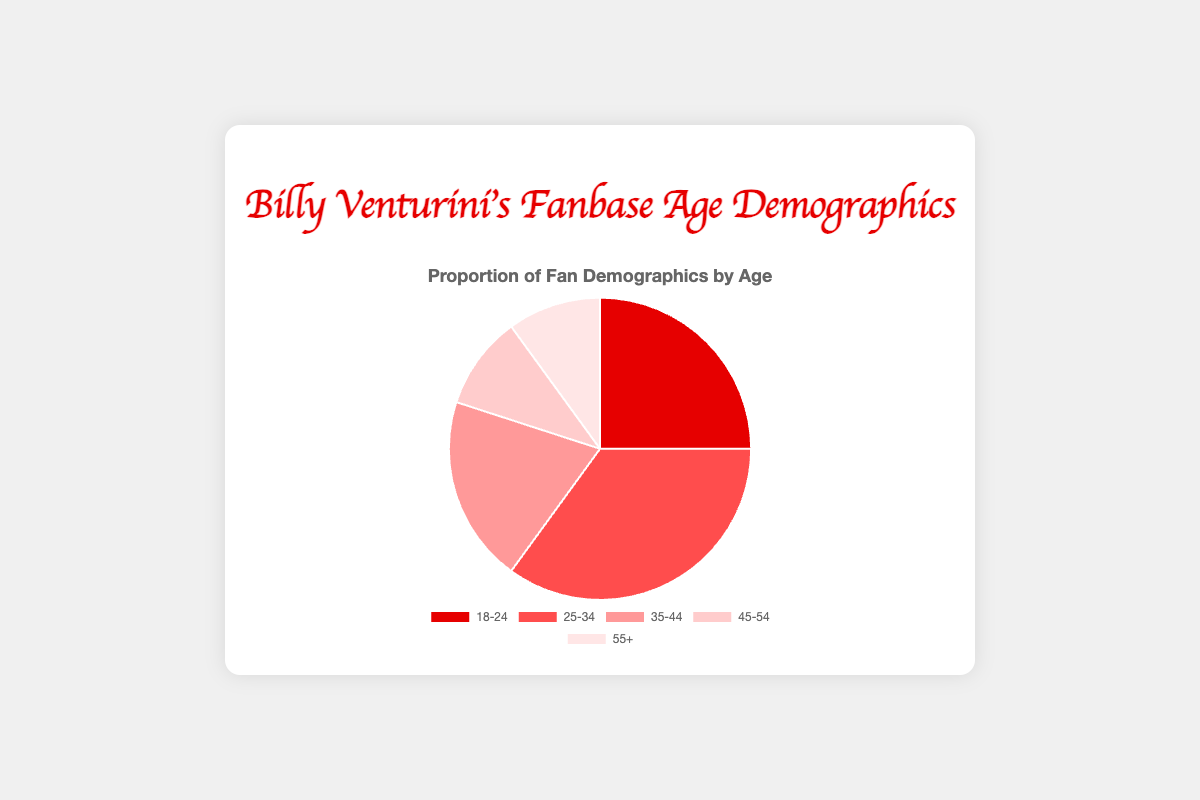Which age group has the largest proportion of fans? The pie chart shows the proportions of fan demographics by age. The slice corresponding to the 25-34 age group takes up the largest portion of the chart.
Answer: 25-34 Which two age groups have the smallest proportion of fans? Observing the pie chart, the smallest portions of the chart are taken up by the 45-54 and 55+ age groups.
Answer: 45-54 and 55+ What is the combined proportion of fans aged 18-24 and 25-34? Adding the proportions of the 18-24 and 25-34 age groups, 0.25 + 0.35 = 0.60. Therefore, the combined proportion is 60%.
Answer: 60% How does the proportion of fans aged 35-44 compare to that of fans aged 55+? The pie chart indicates that the proportion of fans aged 35-44 is 20%, while the proportion of fans aged 55+ is 10%. Hence, the 35-44 age group has a proportion twice as large as the 55+ age group.
Answer: 35-44 has twice the proportion of 55+ What is the difference in the proportion of fans between the 25-34 and 45-54 age groups? The proportion of fans aged 25-34 is 35%, and the proportion of fans aged 45-54 is 10%. Subtracting these: 0.35 - 0.10 = 0.25, or 25%.
Answer: 25% If you were to combine the fan proportions of the 45-54 and 55+ age groups, what fraction of the total fanbase would they represent? Adding the proportions of the 45-54 and 55+ age groups, 0.10 + 0.10 = 0.20. Therefore, the combined fraction is 20%.
Answer: 20% Which age group is represented by the lightest color in the pie chart? The pie chart shows different shades of red for each age group. The lightest color is used for the 55+ age group.
Answer: 55+ By how much does the proportion of fans aged 18-24 exceed the proportion of fans aged 45-54? The pie chart shows that the proportion for 18-24 is 25% and for 45-54 is 10%. The difference is 0.25 - 0.10 = 0.15, or 15%.
Answer: 15% What is the average proportion of fans in the age groups 35-44, 45-54, and 55+? Adding the proportions: 0.20 + 0.10 + 0.10 = 0.40. Dividing by 3 gives 0.40 / 3 ≈ 0.1333, or approximately 13.33%.
Answer: 13.33% 